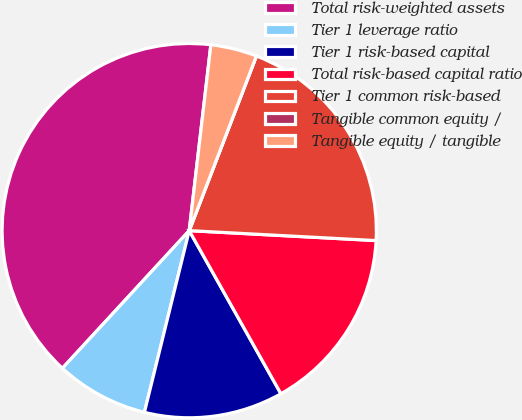<chart> <loc_0><loc_0><loc_500><loc_500><pie_chart><fcel>Total risk-weighted assets<fcel>Tier 1 leverage ratio<fcel>Tier 1 risk-based capital<fcel>Total risk-based capital ratio<fcel>Tier 1 common risk-based<fcel>Tangible common equity /<fcel>Tangible equity / tangible<nl><fcel>39.99%<fcel>8.0%<fcel>12.0%<fcel>16.0%<fcel>20.0%<fcel>0.0%<fcel>4.0%<nl></chart> 